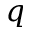Convert formula to latex. <formula><loc_0><loc_0><loc_500><loc_500>q</formula> 